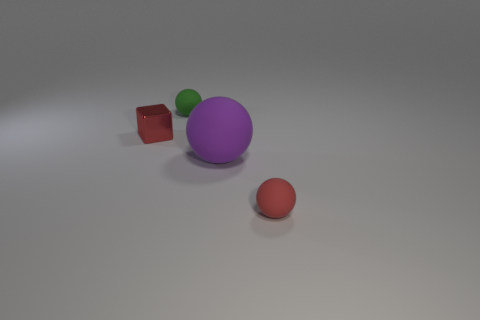Are there fewer big purple matte objects that are to the right of the large matte object than big yellow shiny blocks?
Ensure brevity in your answer.  No. There is a tiny green object that is the same material as the big purple thing; what shape is it?
Make the answer very short. Sphere. Do the purple sphere and the tiny red ball have the same material?
Make the answer very short. Yes. Is the number of small green rubber objects that are in front of the red matte thing less than the number of large things behind the large purple rubber thing?
Your response must be concise. No. The object that is the same color as the shiny cube is what size?
Give a very brief answer. Small. There is a small red object that is in front of the small red object behind the large purple rubber ball; what number of small red matte spheres are right of it?
Offer a very short reply. 0. Is there a matte object that has the same color as the cube?
Offer a very short reply. Yes. The ball that is the same size as the green thing is what color?
Ensure brevity in your answer.  Red. Are there any other green things of the same shape as the large matte object?
Give a very brief answer. Yes. The thing that is the same color as the shiny cube is what shape?
Provide a short and direct response. Sphere. 